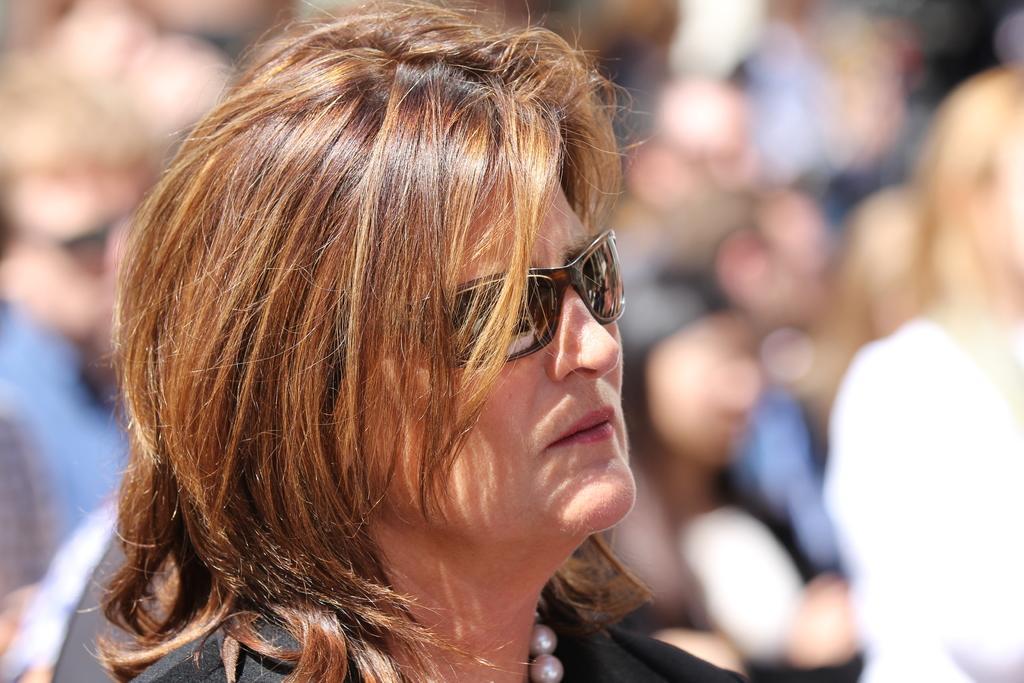Describe this image in one or two sentences. In this image in the front there is a person and the background is blurry. 